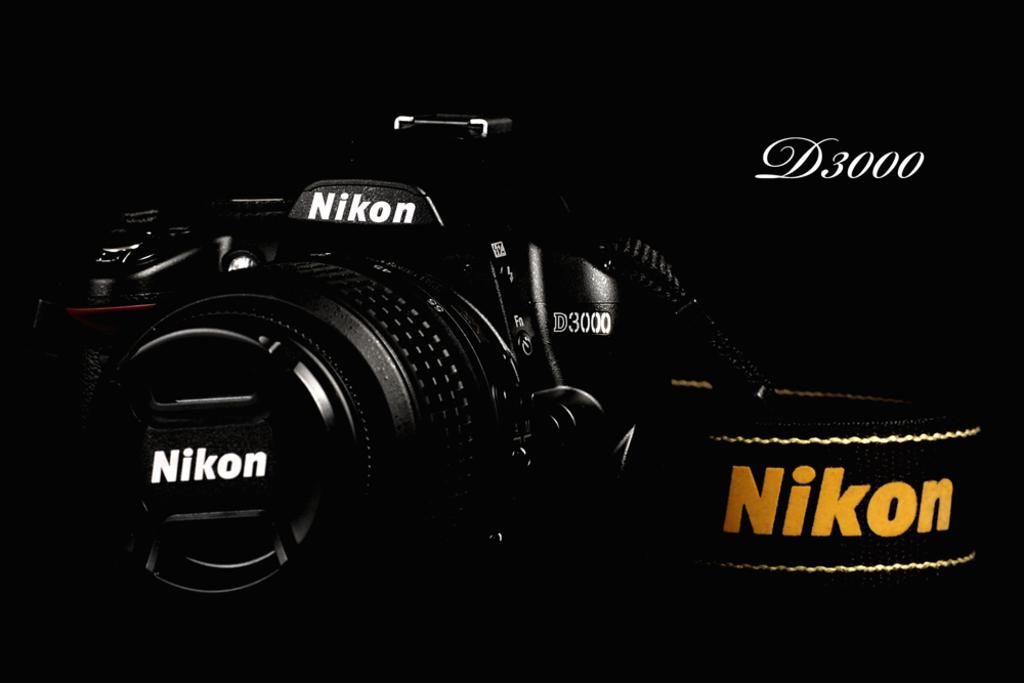What is the main object in the foreground of the image? There is a camera in the foreground of the image. What brand is the camera? The camera has the text "nikon" written on it. What type of net can be seen in the image? There is no net present in the image; it features a camera with the text "nikon" written on it. What kind of bean is visible in the image? There are no beans present in the image. 